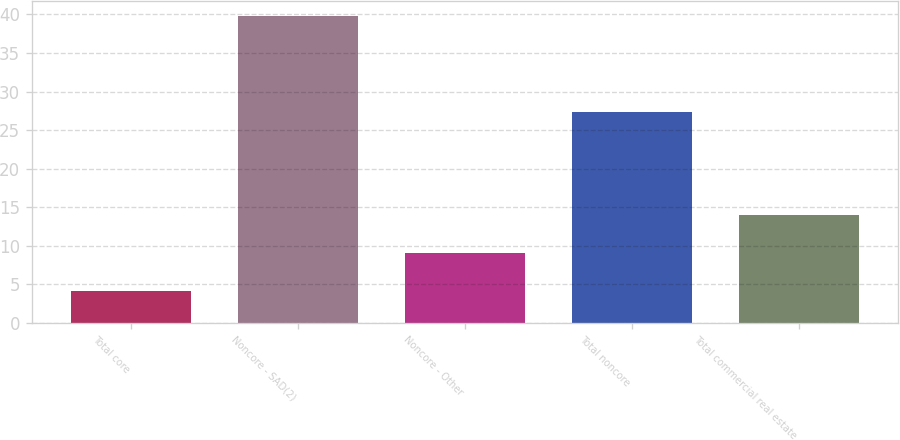Convert chart to OTSL. <chart><loc_0><loc_0><loc_500><loc_500><bar_chart><fcel>Total core<fcel>Noncore - SAD(2)<fcel>Noncore - Other<fcel>Total noncore<fcel>Total commercial real estate<nl><fcel>4.08<fcel>39.8<fcel>9.06<fcel>27.33<fcel>13.96<nl></chart> 